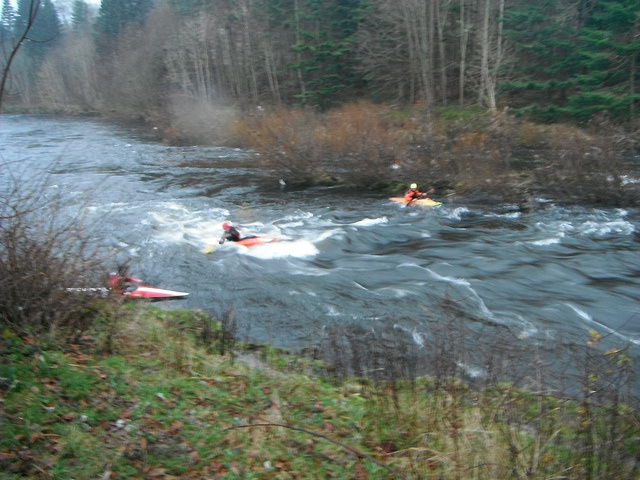Describe the objects in this image and their specific colors. I can see boat in ivory, gray, white, darkgray, and lightpink tones, boat in white, lightgray, lightpink, lightblue, and darkgray tones, people in white, gray, brown, and maroon tones, boat in white, khaki, darkgray, gray, and tan tones, and people in white, gray, black, darkgray, and brown tones in this image. 